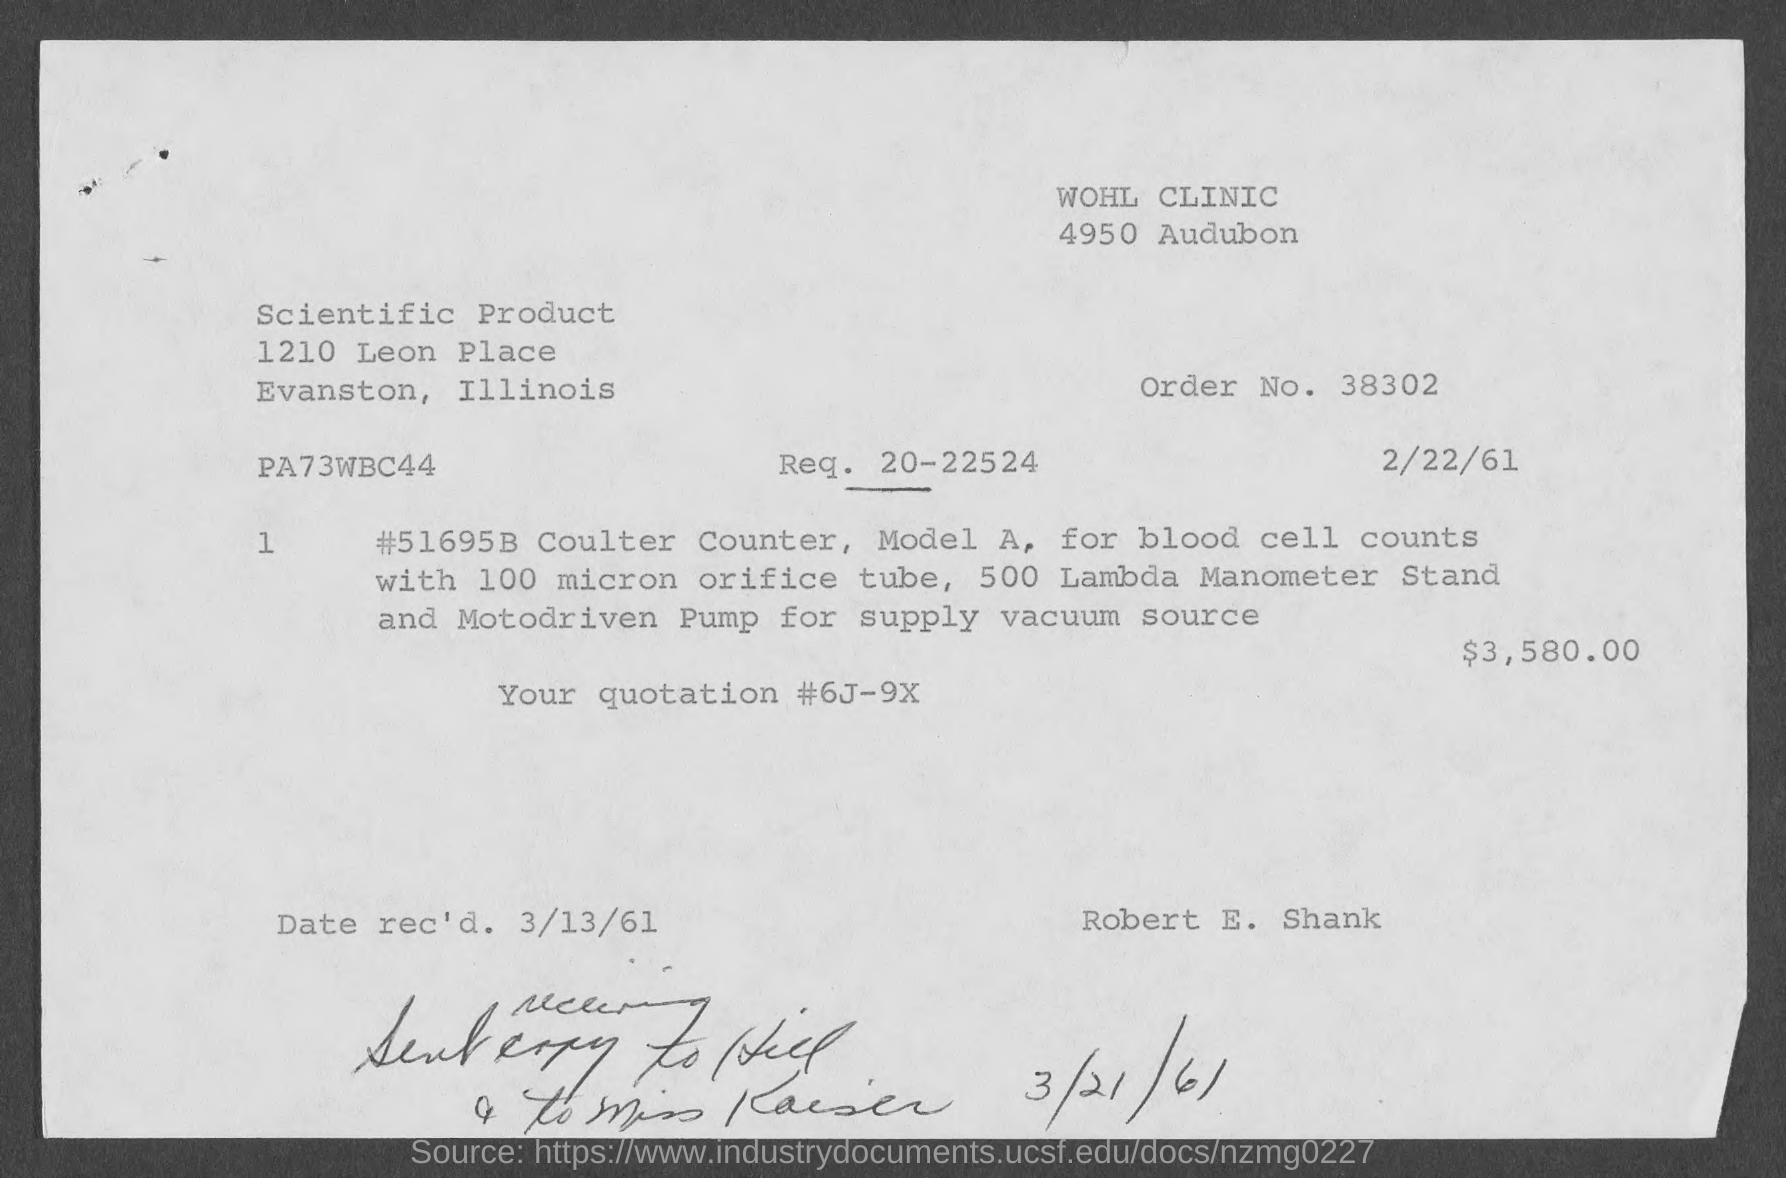What is the order no.?
Offer a very short reply. 38302. What is req. no?
Offer a terse response. 20-22524. What is the date of rec'd?
Ensure brevity in your answer.  3/13/61. What is the amount of quotation ?
Your answer should be compact. $3,580.00. 